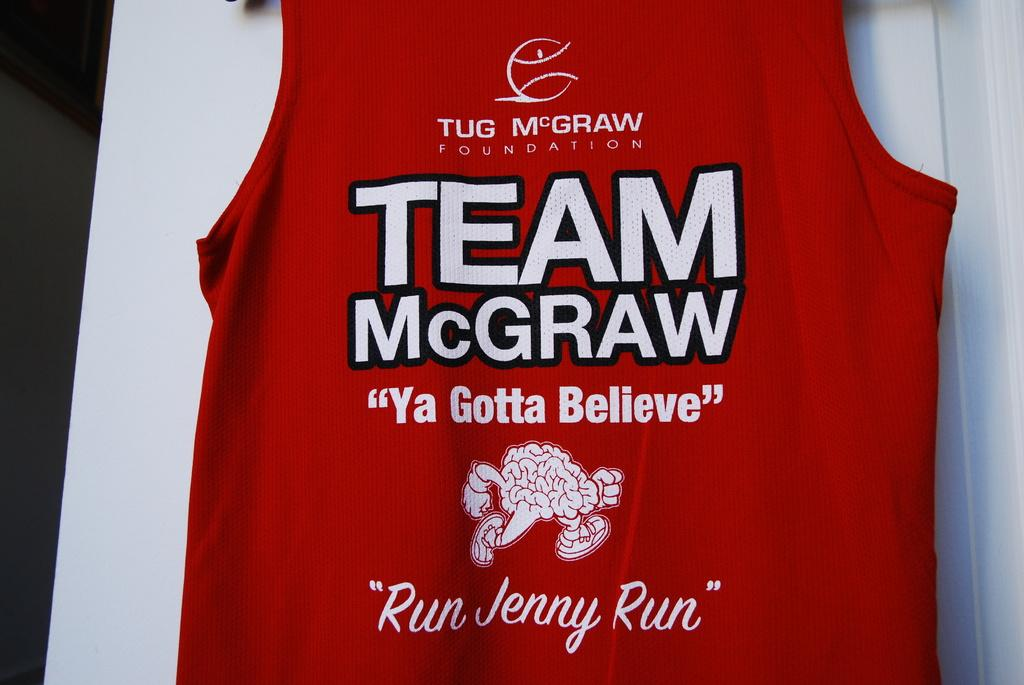<image>
Relay a brief, clear account of the picture shown. A red jersey that says Team McGraw on it. 